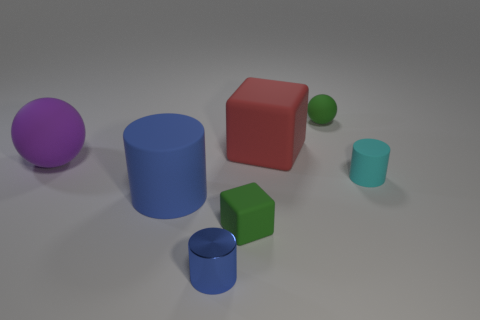There is a thing that is the same color as the tiny sphere; what shape is it?
Give a very brief answer. Cube. There is a rubber cylinder that is the same color as the metallic cylinder; what is its size?
Offer a terse response. Large. What number of other objects are the same size as the cyan object?
Offer a terse response. 3. What is the tiny green thing in front of the cyan matte thing made of?
Ensure brevity in your answer.  Rubber. Is the big blue thing the same shape as the purple matte thing?
Provide a short and direct response. No. What number of other objects are there of the same shape as the red object?
Your answer should be very brief. 1. The big matte thing behind the large matte sphere is what color?
Your answer should be very brief. Red. Is the red object the same size as the purple rubber object?
Ensure brevity in your answer.  Yes. What is the material of the green thing in front of the tiny green object that is behind the small green matte cube?
Offer a very short reply. Rubber. What number of small things have the same color as the tiny cube?
Your answer should be very brief. 1. 